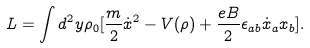<formula> <loc_0><loc_0><loc_500><loc_500>L = \int d ^ { 2 } y \rho _ { 0 } [ \frac { m } { 2 } \dot { x } ^ { 2 } - V ( \rho ) + \frac { e B } { 2 } \epsilon _ { a b } \dot { x } _ { a } x _ { b } ] .</formula> 